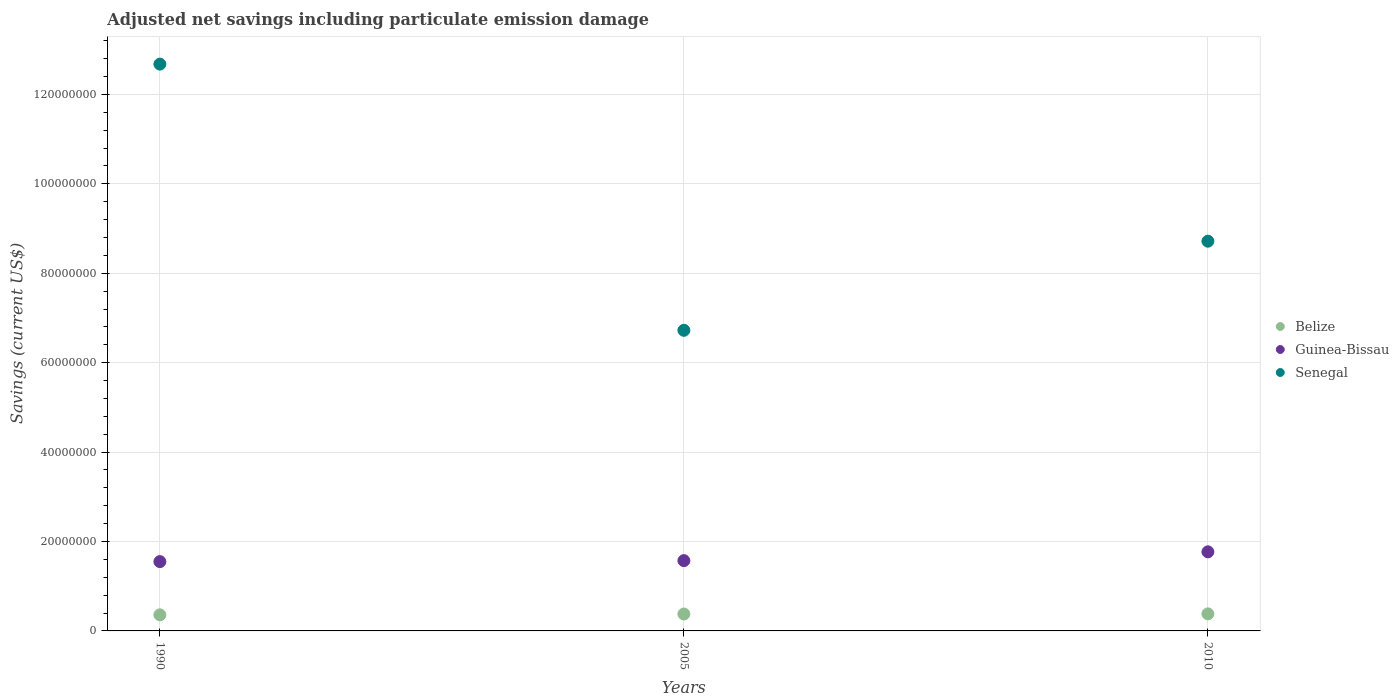Is the number of dotlines equal to the number of legend labels?
Offer a very short reply. Yes. What is the net savings in Guinea-Bissau in 2005?
Your answer should be very brief. 1.57e+07. Across all years, what is the maximum net savings in Guinea-Bissau?
Provide a short and direct response. 1.77e+07. Across all years, what is the minimum net savings in Guinea-Bissau?
Give a very brief answer. 1.55e+07. In which year was the net savings in Guinea-Bissau maximum?
Offer a very short reply. 2010. In which year was the net savings in Belize minimum?
Offer a terse response. 1990. What is the total net savings in Guinea-Bissau in the graph?
Give a very brief answer. 4.89e+07. What is the difference between the net savings in Senegal in 1990 and that in 2005?
Provide a short and direct response. 5.95e+07. What is the difference between the net savings in Senegal in 2005 and the net savings in Guinea-Bissau in 1990?
Make the answer very short. 5.17e+07. What is the average net savings in Guinea-Bissau per year?
Make the answer very short. 1.63e+07. In the year 2010, what is the difference between the net savings in Belize and net savings in Guinea-Bissau?
Your answer should be compact. -1.39e+07. In how many years, is the net savings in Belize greater than 64000000 US$?
Your answer should be very brief. 0. What is the ratio of the net savings in Guinea-Bissau in 1990 to that in 2005?
Your answer should be compact. 0.99. Is the net savings in Guinea-Bissau in 1990 less than that in 2005?
Make the answer very short. Yes. Is the difference between the net savings in Belize in 2005 and 2010 greater than the difference between the net savings in Guinea-Bissau in 2005 and 2010?
Offer a very short reply. Yes. What is the difference between the highest and the second highest net savings in Belize?
Keep it short and to the point. 3.43e+04. What is the difference between the highest and the lowest net savings in Belize?
Make the answer very short. 2.20e+05. Is it the case that in every year, the sum of the net savings in Guinea-Bissau and net savings in Belize  is greater than the net savings in Senegal?
Provide a short and direct response. No. Does the net savings in Senegal monotonically increase over the years?
Give a very brief answer. No. Is the net savings in Senegal strictly greater than the net savings in Belize over the years?
Keep it short and to the point. Yes. Is the net savings in Senegal strictly less than the net savings in Belize over the years?
Your response must be concise. No. How many years are there in the graph?
Provide a succinct answer. 3. What is the difference between two consecutive major ticks on the Y-axis?
Offer a very short reply. 2.00e+07. Are the values on the major ticks of Y-axis written in scientific E-notation?
Provide a short and direct response. No. Does the graph contain grids?
Offer a terse response. Yes. How many legend labels are there?
Your response must be concise. 3. How are the legend labels stacked?
Give a very brief answer. Vertical. What is the title of the graph?
Offer a very short reply. Adjusted net savings including particulate emission damage. What is the label or title of the Y-axis?
Offer a very short reply. Savings (current US$). What is the Savings (current US$) in Belize in 1990?
Your response must be concise. 3.60e+06. What is the Savings (current US$) in Guinea-Bissau in 1990?
Your answer should be compact. 1.55e+07. What is the Savings (current US$) of Senegal in 1990?
Provide a short and direct response. 1.27e+08. What is the Savings (current US$) of Belize in 2005?
Offer a terse response. 3.78e+06. What is the Savings (current US$) of Guinea-Bissau in 2005?
Provide a short and direct response. 1.57e+07. What is the Savings (current US$) in Senegal in 2005?
Offer a very short reply. 6.72e+07. What is the Savings (current US$) of Belize in 2010?
Your response must be concise. 3.82e+06. What is the Savings (current US$) of Guinea-Bissau in 2010?
Keep it short and to the point. 1.77e+07. What is the Savings (current US$) of Senegal in 2010?
Make the answer very short. 8.72e+07. Across all years, what is the maximum Savings (current US$) in Belize?
Offer a very short reply. 3.82e+06. Across all years, what is the maximum Savings (current US$) in Guinea-Bissau?
Keep it short and to the point. 1.77e+07. Across all years, what is the maximum Savings (current US$) of Senegal?
Your answer should be compact. 1.27e+08. Across all years, what is the minimum Savings (current US$) of Belize?
Ensure brevity in your answer.  3.60e+06. Across all years, what is the minimum Savings (current US$) of Guinea-Bissau?
Offer a very short reply. 1.55e+07. Across all years, what is the minimum Savings (current US$) in Senegal?
Your answer should be very brief. 6.72e+07. What is the total Savings (current US$) of Belize in the graph?
Your answer should be very brief. 1.12e+07. What is the total Savings (current US$) of Guinea-Bissau in the graph?
Offer a very short reply. 4.89e+07. What is the total Savings (current US$) of Senegal in the graph?
Give a very brief answer. 2.81e+08. What is the difference between the Savings (current US$) of Belize in 1990 and that in 2005?
Provide a succinct answer. -1.86e+05. What is the difference between the Savings (current US$) in Guinea-Bissau in 1990 and that in 2005?
Your answer should be very brief. -2.18e+05. What is the difference between the Savings (current US$) in Senegal in 1990 and that in 2005?
Your response must be concise. 5.95e+07. What is the difference between the Savings (current US$) in Belize in 1990 and that in 2010?
Your answer should be very brief. -2.20e+05. What is the difference between the Savings (current US$) of Guinea-Bissau in 1990 and that in 2010?
Your response must be concise. -2.19e+06. What is the difference between the Savings (current US$) of Senegal in 1990 and that in 2010?
Your response must be concise. 3.96e+07. What is the difference between the Savings (current US$) in Belize in 2005 and that in 2010?
Make the answer very short. -3.43e+04. What is the difference between the Savings (current US$) in Guinea-Bissau in 2005 and that in 2010?
Provide a short and direct response. -1.97e+06. What is the difference between the Savings (current US$) in Senegal in 2005 and that in 2010?
Offer a terse response. -1.99e+07. What is the difference between the Savings (current US$) in Belize in 1990 and the Savings (current US$) in Guinea-Bissau in 2005?
Give a very brief answer. -1.21e+07. What is the difference between the Savings (current US$) of Belize in 1990 and the Savings (current US$) of Senegal in 2005?
Give a very brief answer. -6.36e+07. What is the difference between the Savings (current US$) of Guinea-Bissau in 1990 and the Savings (current US$) of Senegal in 2005?
Your response must be concise. -5.17e+07. What is the difference between the Savings (current US$) in Belize in 1990 and the Savings (current US$) in Guinea-Bissau in 2010?
Provide a succinct answer. -1.41e+07. What is the difference between the Savings (current US$) of Belize in 1990 and the Savings (current US$) of Senegal in 2010?
Offer a terse response. -8.36e+07. What is the difference between the Savings (current US$) in Guinea-Bissau in 1990 and the Savings (current US$) in Senegal in 2010?
Your answer should be very brief. -7.17e+07. What is the difference between the Savings (current US$) of Belize in 2005 and the Savings (current US$) of Guinea-Bissau in 2010?
Your answer should be very brief. -1.39e+07. What is the difference between the Savings (current US$) of Belize in 2005 and the Savings (current US$) of Senegal in 2010?
Ensure brevity in your answer.  -8.34e+07. What is the difference between the Savings (current US$) in Guinea-Bissau in 2005 and the Savings (current US$) in Senegal in 2010?
Offer a terse response. -7.15e+07. What is the average Savings (current US$) of Belize per year?
Make the answer very short. 3.73e+06. What is the average Savings (current US$) of Guinea-Bissau per year?
Provide a succinct answer. 1.63e+07. What is the average Savings (current US$) of Senegal per year?
Your answer should be very brief. 9.37e+07. In the year 1990, what is the difference between the Savings (current US$) in Belize and Savings (current US$) in Guinea-Bissau?
Offer a terse response. -1.19e+07. In the year 1990, what is the difference between the Savings (current US$) in Belize and Savings (current US$) in Senegal?
Make the answer very short. -1.23e+08. In the year 1990, what is the difference between the Savings (current US$) of Guinea-Bissau and Savings (current US$) of Senegal?
Keep it short and to the point. -1.11e+08. In the year 2005, what is the difference between the Savings (current US$) in Belize and Savings (current US$) in Guinea-Bissau?
Your answer should be very brief. -1.19e+07. In the year 2005, what is the difference between the Savings (current US$) of Belize and Savings (current US$) of Senegal?
Offer a terse response. -6.35e+07. In the year 2005, what is the difference between the Savings (current US$) of Guinea-Bissau and Savings (current US$) of Senegal?
Ensure brevity in your answer.  -5.15e+07. In the year 2010, what is the difference between the Savings (current US$) in Belize and Savings (current US$) in Guinea-Bissau?
Your answer should be very brief. -1.39e+07. In the year 2010, what is the difference between the Savings (current US$) of Belize and Savings (current US$) of Senegal?
Give a very brief answer. -8.34e+07. In the year 2010, what is the difference between the Savings (current US$) in Guinea-Bissau and Savings (current US$) in Senegal?
Give a very brief answer. -6.95e+07. What is the ratio of the Savings (current US$) of Belize in 1990 to that in 2005?
Offer a very short reply. 0.95. What is the ratio of the Savings (current US$) of Guinea-Bissau in 1990 to that in 2005?
Keep it short and to the point. 0.99. What is the ratio of the Savings (current US$) of Senegal in 1990 to that in 2005?
Provide a succinct answer. 1.89. What is the ratio of the Savings (current US$) of Belize in 1990 to that in 2010?
Give a very brief answer. 0.94. What is the ratio of the Savings (current US$) of Guinea-Bissau in 1990 to that in 2010?
Your answer should be very brief. 0.88. What is the ratio of the Savings (current US$) in Senegal in 1990 to that in 2010?
Your answer should be compact. 1.45. What is the ratio of the Savings (current US$) of Belize in 2005 to that in 2010?
Your response must be concise. 0.99. What is the ratio of the Savings (current US$) of Guinea-Bissau in 2005 to that in 2010?
Your answer should be very brief. 0.89. What is the ratio of the Savings (current US$) in Senegal in 2005 to that in 2010?
Offer a very short reply. 0.77. What is the difference between the highest and the second highest Savings (current US$) in Belize?
Keep it short and to the point. 3.43e+04. What is the difference between the highest and the second highest Savings (current US$) in Guinea-Bissau?
Keep it short and to the point. 1.97e+06. What is the difference between the highest and the second highest Savings (current US$) of Senegal?
Offer a very short reply. 3.96e+07. What is the difference between the highest and the lowest Savings (current US$) in Belize?
Your answer should be compact. 2.20e+05. What is the difference between the highest and the lowest Savings (current US$) in Guinea-Bissau?
Provide a succinct answer. 2.19e+06. What is the difference between the highest and the lowest Savings (current US$) in Senegal?
Offer a very short reply. 5.95e+07. 